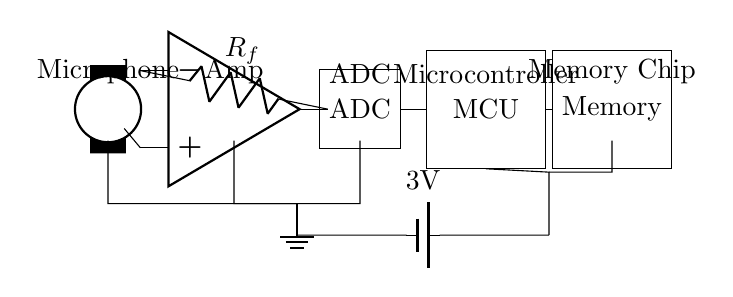What is the purpose of the microphone? The microphone captures audio signals and converts them into electrical signals, which are then sent to the amplifier.
Answer: Capturing audio What component amplifies the microphone signal? The amplifier, often designated as "Amp" in the circuit, takes the weak electrical signal from the microphone and boosts its strength for further processing.
Answer: Amplifier What type of memory chip is used in this circuit? The memory chip stores the processed audio data received from the microcontroller, allowing for playback or retrieval of captured plot ideas.
Answer: Memory Chip How is the circuit powered? The circuit is powered by a battery supplying 3V, which connects to various components to provide the necessary voltage for operation.
Answer: Battery What does the ADC convert? The analog-to-digital converter (ADC) takes the analog signal from the amplifier and converts it into a digital format that the microcontroller can process.
Answer: Analog signal What role does the microcontroller play in the circuit? The microcontroller processes the digital audio data received from the ADC and manages the data flow to the memory chip for storage.
Answer: Processing data Why is using a low power design important for this voice recorder? Low power designs extend battery life, making devices like voice recorders more portable and efficient for on-the-go use.
Answer: Extend battery life 